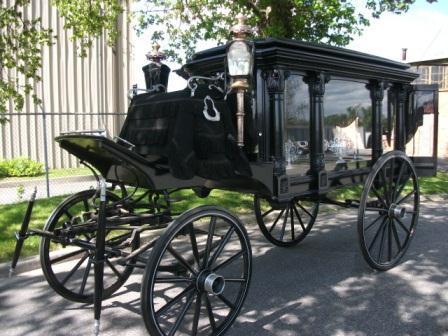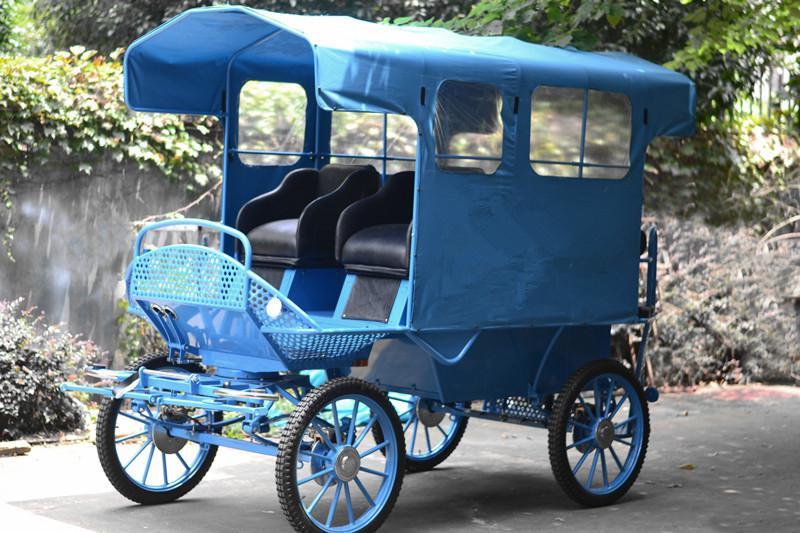The first image is the image on the left, the second image is the image on the right. Assess this claim about the two images: "At least one buggy has no cover on the passenger area.". Correct or not? Answer yes or no. No. 